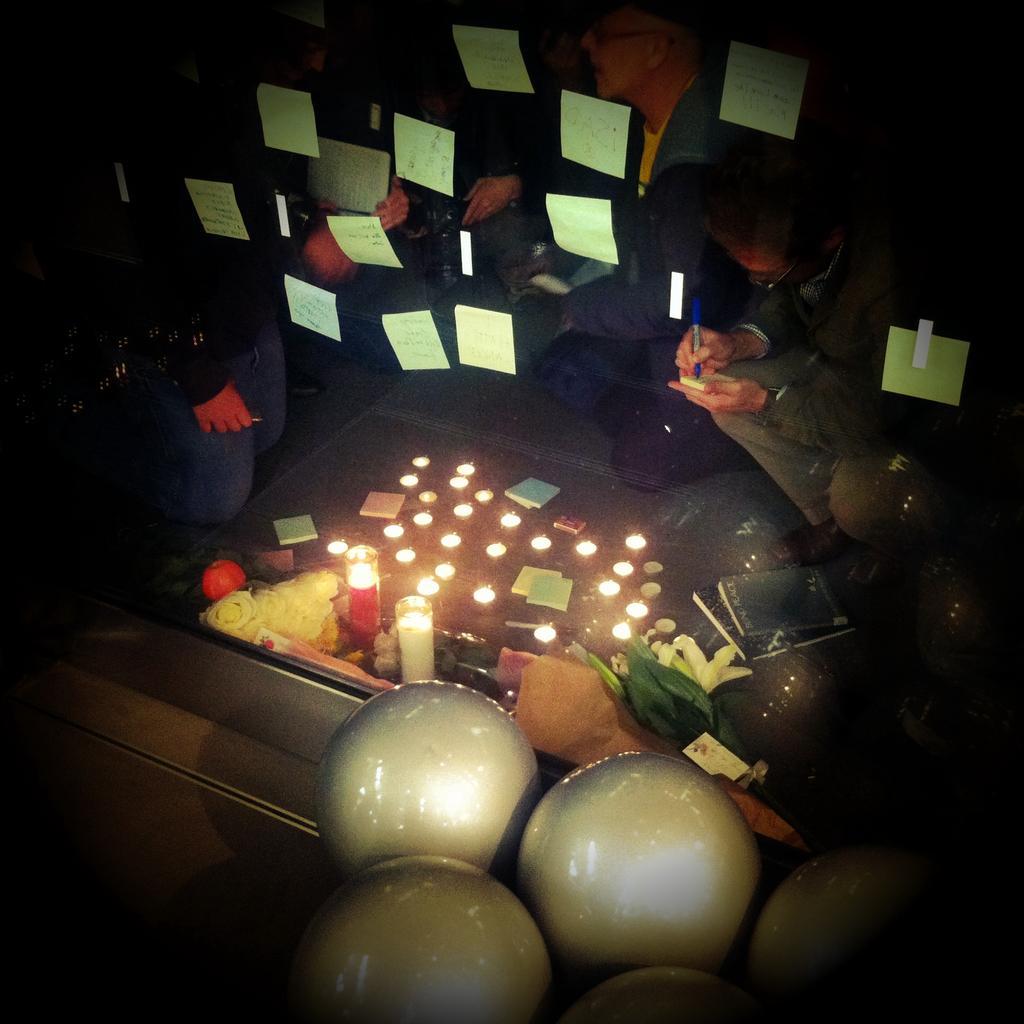Describe this image in one or two sentences. In the image there is a glass and there are sticky notes attached to the glass, in front of the glass there are balloons and behind that there are candles and around the candles there are few people. 